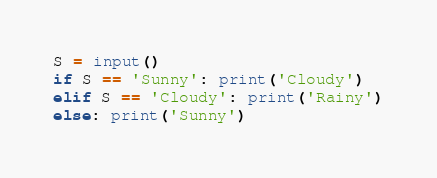<code> <loc_0><loc_0><loc_500><loc_500><_Python_>S = input()
if S == 'Sunny': print('Cloudy')
elif S == 'Cloudy': print('Rainy')
else: print('Sunny')</code> 